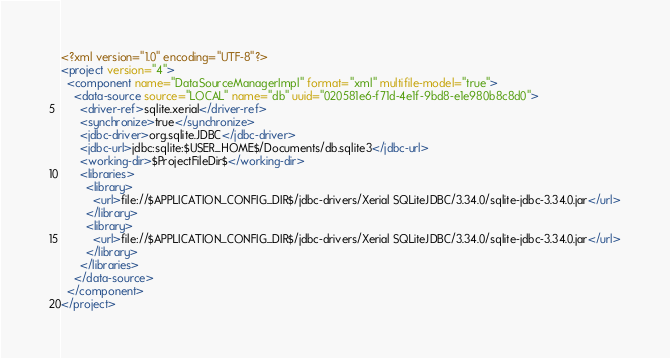Convert code to text. <code><loc_0><loc_0><loc_500><loc_500><_XML_><?xml version="1.0" encoding="UTF-8"?>
<project version="4">
  <component name="DataSourceManagerImpl" format="xml" multifile-model="true">
    <data-source source="LOCAL" name="db" uuid="020581e6-f71d-4e1f-9bd8-e1e980b8c8d0">
      <driver-ref>sqlite.xerial</driver-ref>
      <synchronize>true</synchronize>
      <jdbc-driver>org.sqlite.JDBC</jdbc-driver>
      <jdbc-url>jdbc:sqlite:$USER_HOME$/Documents/db.sqlite3</jdbc-url>
      <working-dir>$ProjectFileDir$</working-dir>
      <libraries>
        <library>
          <url>file://$APPLICATION_CONFIG_DIR$/jdbc-drivers/Xerial SQLiteJDBC/3.34.0/sqlite-jdbc-3.34.0.jar</url>
        </library>
        <library>
          <url>file://$APPLICATION_CONFIG_DIR$/jdbc-drivers/Xerial SQLiteJDBC/3.34.0/sqlite-jdbc-3.34.0.jar</url>
        </library>
      </libraries>
    </data-source>
  </component>
</project></code> 